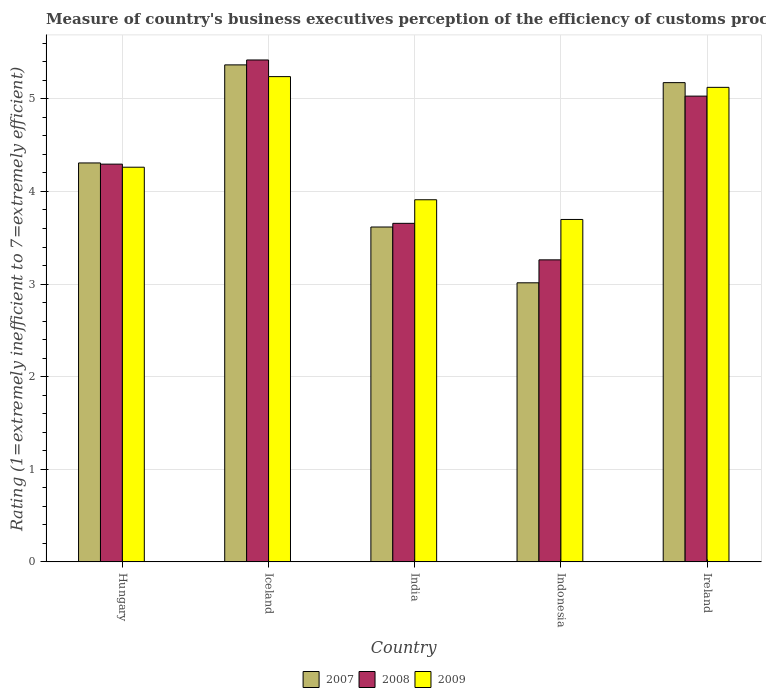How many different coloured bars are there?
Give a very brief answer. 3. How many bars are there on the 3rd tick from the right?
Give a very brief answer. 3. What is the label of the 5th group of bars from the left?
Your answer should be very brief. Ireland. What is the rating of the efficiency of customs procedure in 2008 in India?
Your answer should be compact. 3.66. Across all countries, what is the maximum rating of the efficiency of customs procedure in 2009?
Provide a short and direct response. 5.24. Across all countries, what is the minimum rating of the efficiency of customs procedure in 2008?
Your answer should be very brief. 3.26. In which country was the rating of the efficiency of customs procedure in 2009 minimum?
Make the answer very short. Indonesia. What is the total rating of the efficiency of customs procedure in 2008 in the graph?
Keep it short and to the point. 21.66. What is the difference between the rating of the efficiency of customs procedure in 2008 in Iceland and that in Ireland?
Provide a succinct answer. 0.39. What is the difference between the rating of the efficiency of customs procedure in 2007 in India and the rating of the efficiency of customs procedure in 2008 in Indonesia?
Your answer should be compact. 0.35. What is the average rating of the efficiency of customs procedure in 2007 per country?
Ensure brevity in your answer.  4.3. What is the difference between the rating of the efficiency of customs procedure of/in 2009 and rating of the efficiency of customs procedure of/in 2008 in Iceland?
Your answer should be very brief. -0.18. What is the ratio of the rating of the efficiency of customs procedure in 2007 in Hungary to that in Iceland?
Provide a succinct answer. 0.8. Is the rating of the efficiency of customs procedure in 2007 in Hungary less than that in India?
Make the answer very short. No. What is the difference between the highest and the second highest rating of the efficiency of customs procedure in 2009?
Make the answer very short. 0.86. What is the difference between the highest and the lowest rating of the efficiency of customs procedure in 2007?
Ensure brevity in your answer.  2.35. What does the 3rd bar from the right in Iceland represents?
Your answer should be very brief. 2007. Are all the bars in the graph horizontal?
Offer a very short reply. No. What is the difference between two consecutive major ticks on the Y-axis?
Provide a succinct answer. 1. Does the graph contain grids?
Your answer should be compact. Yes. Where does the legend appear in the graph?
Your answer should be very brief. Bottom center. What is the title of the graph?
Keep it short and to the point. Measure of country's business executives perception of the efficiency of customs procedures. Does "1978" appear as one of the legend labels in the graph?
Ensure brevity in your answer.  No. What is the label or title of the Y-axis?
Your response must be concise. Rating (1=extremely inefficient to 7=extremely efficient). What is the Rating (1=extremely inefficient to 7=extremely efficient) of 2007 in Hungary?
Make the answer very short. 4.31. What is the Rating (1=extremely inefficient to 7=extremely efficient) of 2008 in Hungary?
Provide a short and direct response. 4.29. What is the Rating (1=extremely inefficient to 7=extremely efficient) in 2009 in Hungary?
Offer a terse response. 4.26. What is the Rating (1=extremely inefficient to 7=extremely efficient) in 2007 in Iceland?
Give a very brief answer. 5.37. What is the Rating (1=extremely inefficient to 7=extremely efficient) in 2008 in Iceland?
Provide a succinct answer. 5.42. What is the Rating (1=extremely inefficient to 7=extremely efficient) in 2009 in Iceland?
Your response must be concise. 5.24. What is the Rating (1=extremely inefficient to 7=extremely efficient) in 2007 in India?
Ensure brevity in your answer.  3.62. What is the Rating (1=extremely inefficient to 7=extremely efficient) of 2008 in India?
Your answer should be very brief. 3.66. What is the Rating (1=extremely inefficient to 7=extremely efficient) in 2009 in India?
Keep it short and to the point. 3.91. What is the Rating (1=extremely inefficient to 7=extremely efficient) in 2007 in Indonesia?
Keep it short and to the point. 3.01. What is the Rating (1=extremely inefficient to 7=extremely efficient) in 2008 in Indonesia?
Your answer should be very brief. 3.26. What is the Rating (1=extremely inefficient to 7=extremely efficient) in 2009 in Indonesia?
Your answer should be compact. 3.7. What is the Rating (1=extremely inefficient to 7=extremely efficient) of 2007 in Ireland?
Offer a terse response. 5.17. What is the Rating (1=extremely inefficient to 7=extremely efficient) in 2008 in Ireland?
Provide a succinct answer. 5.03. What is the Rating (1=extremely inefficient to 7=extremely efficient) in 2009 in Ireland?
Keep it short and to the point. 5.12. Across all countries, what is the maximum Rating (1=extremely inefficient to 7=extremely efficient) in 2007?
Offer a terse response. 5.37. Across all countries, what is the maximum Rating (1=extremely inefficient to 7=extremely efficient) of 2008?
Make the answer very short. 5.42. Across all countries, what is the maximum Rating (1=extremely inefficient to 7=extremely efficient) of 2009?
Give a very brief answer. 5.24. Across all countries, what is the minimum Rating (1=extremely inefficient to 7=extremely efficient) of 2007?
Offer a terse response. 3.01. Across all countries, what is the minimum Rating (1=extremely inefficient to 7=extremely efficient) of 2008?
Ensure brevity in your answer.  3.26. Across all countries, what is the minimum Rating (1=extremely inefficient to 7=extremely efficient) in 2009?
Provide a short and direct response. 3.7. What is the total Rating (1=extremely inefficient to 7=extremely efficient) of 2007 in the graph?
Your answer should be very brief. 21.48. What is the total Rating (1=extremely inefficient to 7=extremely efficient) in 2008 in the graph?
Make the answer very short. 21.66. What is the total Rating (1=extremely inefficient to 7=extremely efficient) of 2009 in the graph?
Your response must be concise. 22.23. What is the difference between the Rating (1=extremely inefficient to 7=extremely efficient) of 2007 in Hungary and that in Iceland?
Your answer should be very brief. -1.06. What is the difference between the Rating (1=extremely inefficient to 7=extremely efficient) in 2008 in Hungary and that in Iceland?
Your answer should be compact. -1.12. What is the difference between the Rating (1=extremely inefficient to 7=extremely efficient) of 2009 in Hungary and that in Iceland?
Provide a succinct answer. -0.98. What is the difference between the Rating (1=extremely inefficient to 7=extremely efficient) of 2007 in Hungary and that in India?
Offer a terse response. 0.69. What is the difference between the Rating (1=extremely inefficient to 7=extremely efficient) in 2008 in Hungary and that in India?
Provide a short and direct response. 0.64. What is the difference between the Rating (1=extremely inefficient to 7=extremely efficient) in 2009 in Hungary and that in India?
Offer a very short reply. 0.35. What is the difference between the Rating (1=extremely inefficient to 7=extremely efficient) of 2007 in Hungary and that in Indonesia?
Provide a short and direct response. 1.29. What is the difference between the Rating (1=extremely inefficient to 7=extremely efficient) of 2008 in Hungary and that in Indonesia?
Your answer should be very brief. 1.03. What is the difference between the Rating (1=extremely inefficient to 7=extremely efficient) of 2009 in Hungary and that in Indonesia?
Keep it short and to the point. 0.56. What is the difference between the Rating (1=extremely inefficient to 7=extremely efficient) of 2007 in Hungary and that in Ireland?
Offer a terse response. -0.87. What is the difference between the Rating (1=extremely inefficient to 7=extremely efficient) in 2008 in Hungary and that in Ireland?
Your answer should be very brief. -0.73. What is the difference between the Rating (1=extremely inefficient to 7=extremely efficient) of 2009 in Hungary and that in Ireland?
Make the answer very short. -0.86. What is the difference between the Rating (1=extremely inefficient to 7=extremely efficient) of 2007 in Iceland and that in India?
Provide a succinct answer. 1.75. What is the difference between the Rating (1=extremely inefficient to 7=extremely efficient) of 2008 in Iceland and that in India?
Your response must be concise. 1.76. What is the difference between the Rating (1=extremely inefficient to 7=extremely efficient) in 2009 in Iceland and that in India?
Give a very brief answer. 1.33. What is the difference between the Rating (1=extremely inefficient to 7=extremely efficient) in 2007 in Iceland and that in Indonesia?
Ensure brevity in your answer.  2.35. What is the difference between the Rating (1=extremely inefficient to 7=extremely efficient) in 2008 in Iceland and that in Indonesia?
Make the answer very short. 2.16. What is the difference between the Rating (1=extremely inefficient to 7=extremely efficient) in 2009 in Iceland and that in Indonesia?
Your answer should be compact. 1.54. What is the difference between the Rating (1=extremely inefficient to 7=extremely efficient) of 2007 in Iceland and that in Ireland?
Keep it short and to the point. 0.19. What is the difference between the Rating (1=extremely inefficient to 7=extremely efficient) of 2008 in Iceland and that in Ireland?
Offer a terse response. 0.39. What is the difference between the Rating (1=extremely inefficient to 7=extremely efficient) of 2009 in Iceland and that in Ireland?
Offer a terse response. 0.12. What is the difference between the Rating (1=extremely inefficient to 7=extremely efficient) of 2007 in India and that in Indonesia?
Give a very brief answer. 0.6. What is the difference between the Rating (1=extremely inefficient to 7=extremely efficient) of 2008 in India and that in Indonesia?
Your answer should be compact. 0.39. What is the difference between the Rating (1=extremely inefficient to 7=extremely efficient) of 2009 in India and that in Indonesia?
Your answer should be very brief. 0.21. What is the difference between the Rating (1=extremely inefficient to 7=extremely efficient) of 2007 in India and that in Ireland?
Provide a succinct answer. -1.56. What is the difference between the Rating (1=extremely inefficient to 7=extremely efficient) in 2008 in India and that in Ireland?
Your answer should be compact. -1.37. What is the difference between the Rating (1=extremely inefficient to 7=extremely efficient) in 2009 in India and that in Ireland?
Your response must be concise. -1.21. What is the difference between the Rating (1=extremely inefficient to 7=extremely efficient) in 2007 in Indonesia and that in Ireland?
Provide a short and direct response. -2.16. What is the difference between the Rating (1=extremely inefficient to 7=extremely efficient) in 2008 in Indonesia and that in Ireland?
Provide a short and direct response. -1.77. What is the difference between the Rating (1=extremely inefficient to 7=extremely efficient) of 2009 in Indonesia and that in Ireland?
Your answer should be compact. -1.43. What is the difference between the Rating (1=extremely inefficient to 7=extremely efficient) of 2007 in Hungary and the Rating (1=extremely inefficient to 7=extremely efficient) of 2008 in Iceland?
Your answer should be very brief. -1.11. What is the difference between the Rating (1=extremely inefficient to 7=extremely efficient) of 2007 in Hungary and the Rating (1=extremely inefficient to 7=extremely efficient) of 2009 in Iceland?
Give a very brief answer. -0.93. What is the difference between the Rating (1=extremely inefficient to 7=extremely efficient) of 2008 in Hungary and the Rating (1=extremely inefficient to 7=extremely efficient) of 2009 in Iceland?
Ensure brevity in your answer.  -0.94. What is the difference between the Rating (1=extremely inefficient to 7=extremely efficient) of 2007 in Hungary and the Rating (1=extremely inefficient to 7=extremely efficient) of 2008 in India?
Make the answer very short. 0.65. What is the difference between the Rating (1=extremely inefficient to 7=extremely efficient) of 2007 in Hungary and the Rating (1=extremely inefficient to 7=extremely efficient) of 2009 in India?
Offer a very short reply. 0.4. What is the difference between the Rating (1=extremely inefficient to 7=extremely efficient) in 2008 in Hungary and the Rating (1=extremely inefficient to 7=extremely efficient) in 2009 in India?
Offer a terse response. 0.38. What is the difference between the Rating (1=extremely inefficient to 7=extremely efficient) of 2007 in Hungary and the Rating (1=extremely inefficient to 7=extremely efficient) of 2008 in Indonesia?
Keep it short and to the point. 1.05. What is the difference between the Rating (1=extremely inefficient to 7=extremely efficient) in 2007 in Hungary and the Rating (1=extremely inefficient to 7=extremely efficient) in 2009 in Indonesia?
Your response must be concise. 0.61. What is the difference between the Rating (1=extremely inefficient to 7=extremely efficient) of 2008 in Hungary and the Rating (1=extremely inefficient to 7=extremely efficient) of 2009 in Indonesia?
Provide a short and direct response. 0.6. What is the difference between the Rating (1=extremely inefficient to 7=extremely efficient) of 2007 in Hungary and the Rating (1=extremely inefficient to 7=extremely efficient) of 2008 in Ireland?
Give a very brief answer. -0.72. What is the difference between the Rating (1=extremely inefficient to 7=extremely efficient) in 2007 in Hungary and the Rating (1=extremely inefficient to 7=extremely efficient) in 2009 in Ireland?
Your answer should be compact. -0.82. What is the difference between the Rating (1=extremely inefficient to 7=extremely efficient) in 2008 in Hungary and the Rating (1=extremely inefficient to 7=extremely efficient) in 2009 in Ireland?
Offer a very short reply. -0.83. What is the difference between the Rating (1=extremely inefficient to 7=extremely efficient) of 2007 in Iceland and the Rating (1=extremely inefficient to 7=extremely efficient) of 2008 in India?
Make the answer very short. 1.71. What is the difference between the Rating (1=extremely inefficient to 7=extremely efficient) in 2007 in Iceland and the Rating (1=extremely inefficient to 7=extremely efficient) in 2009 in India?
Offer a very short reply. 1.46. What is the difference between the Rating (1=extremely inefficient to 7=extremely efficient) of 2008 in Iceland and the Rating (1=extremely inefficient to 7=extremely efficient) of 2009 in India?
Your answer should be very brief. 1.51. What is the difference between the Rating (1=extremely inefficient to 7=extremely efficient) of 2007 in Iceland and the Rating (1=extremely inefficient to 7=extremely efficient) of 2008 in Indonesia?
Provide a succinct answer. 2.11. What is the difference between the Rating (1=extremely inefficient to 7=extremely efficient) of 2007 in Iceland and the Rating (1=extremely inefficient to 7=extremely efficient) of 2009 in Indonesia?
Provide a succinct answer. 1.67. What is the difference between the Rating (1=extremely inefficient to 7=extremely efficient) of 2008 in Iceland and the Rating (1=extremely inefficient to 7=extremely efficient) of 2009 in Indonesia?
Keep it short and to the point. 1.72. What is the difference between the Rating (1=extremely inefficient to 7=extremely efficient) of 2007 in Iceland and the Rating (1=extremely inefficient to 7=extremely efficient) of 2008 in Ireland?
Make the answer very short. 0.34. What is the difference between the Rating (1=extremely inefficient to 7=extremely efficient) in 2007 in Iceland and the Rating (1=extremely inefficient to 7=extremely efficient) in 2009 in Ireland?
Give a very brief answer. 0.24. What is the difference between the Rating (1=extremely inefficient to 7=extremely efficient) in 2008 in Iceland and the Rating (1=extremely inefficient to 7=extremely efficient) in 2009 in Ireland?
Give a very brief answer. 0.3. What is the difference between the Rating (1=extremely inefficient to 7=extremely efficient) of 2007 in India and the Rating (1=extremely inefficient to 7=extremely efficient) of 2008 in Indonesia?
Your answer should be very brief. 0.35. What is the difference between the Rating (1=extremely inefficient to 7=extremely efficient) of 2007 in India and the Rating (1=extremely inefficient to 7=extremely efficient) of 2009 in Indonesia?
Offer a very short reply. -0.08. What is the difference between the Rating (1=extremely inefficient to 7=extremely efficient) of 2008 in India and the Rating (1=extremely inefficient to 7=extremely efficient) of 2009 in Indonesia?
Offer a very short reply. -0.04. What is the difference between the Rating (1=extremely inefficient to 7=extremely efficient) of 2007 in India and the Rating (1=extremely inefficient to 7=extremely efficient) of 2008 in Ireland?
Your answer should be compact. -1.41. What is the difference between the Rating (1=extremely inefficient to 7=extremely efficient) of 2007 in India and the Rating (1=extremely inefficient to 7=extremely efficient) of 2009 in Ireland?
Ensure brevity in your answer.  -1.51. What is the difference between the Rating (1=extremely inefficient to 7=extremely efficient) in 2008 in India and the Rating (1=extremely inefficient to 7=extremely efficient) in 2009 in Ireland?
Make the answer very short. -1.47. What is the difference between the Rating (1=extremely inefficient to 7=extremely efficient) in 2007 in Indonesia and the Rating (1=extremely inefficient to 7=extremely efficient) in 2008 in Ireland?
Your answer should be very brief. -2.02. What is the difference between the Rating (1=extremely inefficient to 7=extremely efficient) in 2007 in Indonesia and the Rating (1=extremely inefficient to 7=extremely efficient) in 2009 in Ireland?
Your answer should be very brief. -2.11. What is the difference between the Rating (1=extremely inefficient to 7=extremely efficient) of 2008 in Indonesia and the Rating (1=extremely inefficient to 7=extremely efficient) of 2009 in Ireland?
Your response must be concise. -1.86. What is the average Rating (1=extremely inefficient to 7=extremely efficient) of 2007 per country?
Keep it short and to the point. 4.3. What is the average Rating (1=extremely inefficient to 7=extremely efficient) of 2008 per country?
Ensure brevity in your answer.  4.33. What is the average Rating (1=extremely inefficient to 7=extremely efficient) in 2009 per country?
Ensure brevity in your answer.  4.45. What is the difference between the Rating (1=extremely inefficient to 7=extremely efficient) of 2007 and Rating (1=extremely inefficient to 7=extremely efficient) of 2008 in Hungary?
Provide a succinct answer. 0.01. What is the difference between the Rating (1=extremely inefficient to 7=extremely efficient) of 2007 and Rating (1=extremely inefficient to 7=extremely efficient) of 2009 in Hungary?
Your response must be concise. 0.05. What is the difference between the Rating (1=extremely inefficient to 7=extremely efficient) in 2008 and Rating (1=extremely inefficient to 7=extremely efficient) in 2009 in Hungary?
Offer a very short reply. 0.03. What is the difference between the Rating (1=extremely inefficient to 7=extremely efficient) in 2007 and Rating (1=extremely inefficient to 7=extremely efficient) in 2008 in Iceland?
Provide a succinct answer. -0.05. What is the difference between the Rating (1=extremely inefficient to 7=extremely efficient) of 2007 and Rating (1=extremely inefficient to 7=extremely efficient) of 2009 in Iceland?
Your answer should be compact. 0.13. What is the difference between the Rating (1=extremely inefficient to 7=extremely efficient) of 2008 and Rating (1=extremely inefficient to 7=extremely efficient) of 2009 in Iceland?
Ensure brevity in your answer.  0.18. What is the difference between the Rating (1=extremely inefficient to 7=extremely efficient) in 2007 and Rating (1=extremely inefficient to 7=extremely efficient) in 2008 in India?
Ensure brevity in your answer.  -0.04. What is the difference between the Rating (1=extremely inefficient to 7=extremely efficient) of 2007 and Rating (1=extremely inefficient to 7=extremely efficient) of 2009 in India?
Provide a succinct answer. -0.29. What is the difference between the Rating (1=extremely inefficient to 7=extremely efficient) in 2008 and Rating (1=extremely inefficient to 7=extremely efficient) in 2009 in India?
Your answer should be very brief. -0.25. What is the difference between the Rating (1=extremely inefficient to 7=extremely efficient) of 2007 and Rating (1=extremely inefficient to 7=extremely efficient) of 2008 in Indonesia?
Make the answer very short. -0.25. What is the difference between the Rating (1=extremely inefficient to 7=extremely efficient) of 2007 and Rating (1=extremely inefficient to 7=extremely efficient) of 2009 in Indonesia?
Provide a succinct answer. -0.68. What is the difference between the Rating (1=extremely inefficient to 7=extremely efficient) in 2008 and Rating (1=extremely inefficient to 7=extremely efficient) in 2009 in Indonesia?
Your answer should be compact. -0.44. What is the difference between the Rating (1=extremely inefficient to 7=extremely efficient) of 2007 and Rating (1=extremely inefficient to 7=extremely efficient) of 2008 in Ireland?
Give a very brief answer. 0.15. What is the difference between the Rating (1=extremely inefficient to 7=extremely efficient) of 2007 and Rating (1=extremely inefficient to 7=extremely efficient) of 2009 in Ireland?
Your answer should be very brief. 0.05. What is the difference between the Rating (1=extremely inefficient to 7=extremely efficient) of 2008 and Rating (1=extremely inefficient to 7=extremely efficient) of 2009 in Ireland?
Make the answer very short. -0.09. What is the ratio of the Rating (1=extremely inefficient to 7=extremely efficient) of 2007 in Hungary to that in Iceland?
Provide a short and direct response. 0.8. What is the ratio of the Rating (1=extremely inefficient to 7=extremely efficient) in 2008 in Hungary to that in Iceland?
Your response must be concise. 0.79. What is the ratio of the Rating (1=extremely inefficient to 7=extremely efficient) of 2009 in Hungary to that in Iceland?
Offer a very short reply. 0.81. What is the ratio of the Rating (1=extremely inefficient to 7=extremely efficient) of 2007 in Hungary to that in India?
Keep it short and to the point. 1.19. What is the ratio of the Rating (1=extremely inefficient to 7=extremely efficient) in 2008 in Hungary to that in India?
Your response must be concise. 1.17. What is the ratio of the Rating (1=extremely inefficient to 7=extremely efficient) in 2009 in Hungary to that in India?
Offer a very short reply. 1.09. What is the ratio of the Rating (1=extremely inefficient to 7=extremely efficient) of 2007 in Hungary to that in Indonesia?
Make the answer very short. 1.43. What is the ratio of the Rating (1=extremely inefficient to 7=extremely efficient) in 2008 in Hungary to that in Indonesia?
Offer a terse response. 1.32. What is the ratio of the Rating (1=extremely inefficient to 7=extremely efficient) in 2009 in Hungary to that in Indonesia?
Make the answer very short. 1.15. What is the ratio of the Rating (1=extremely inefficient to 7=extremely efficient) in 2007 in Hungary to that in Ireland?
Provide a short and direct response. 0.83. What is the ratio of the Rating (1=extremely inefficient to 7=extremely efficient) in 2008 in Hungary to that in Ireland?
Ensure brevity in your answer.  0.85. What is the ratio of the Rating (1=extremely inefficient to 7=extremely efficient) in 2009 in Hungary to that in Ireland?
Provide a succinct answer. 0.83. What is the ratio of the Rating (1=extremely inefficient to 7=extremely efficient) in 2007 in Iceland to that in India?
Make the answer very short. 1.48. What is the ratio of the Rating (1=extremely inefficient to 7=extremely efficient) of 2008 in Iceland to that in India?
Provide a short and direct response. 1.48. What is the ratio of the Rating (1=extremely inefficient to 7=extremely efficient) in 2009 in Iceland to that in India?
Your answer should be very brief. 1.34. What is the ratio of the Rating (1=extremely inefficient to 7=extremely efficient) in 2007 in Iceland to that in Indonesia?
Offer a very short reply. 1.78. What is the ratio of the Rating (1=extremely inefficient to 7=extremely efficient) in 2008 in Iceland to that in Indonesia?
Your response must be concise. 1.66. What is the ratio of the Rating (1=extremely inefficient to 7=extremely efficient) of 2009 in Iceland to that in Indonesia?
Provide a short and direct response. 1.42. What is the ratio of the Rating (1=extremely inefficient to 7=extremely efficient) of 2007 in Iceland to that in Ireland?
Offer a very short reply. 1.04. What is the ratio of the Rating (1=extremely inefficient to 7=extremely efficient) of 2008 in Iceland to that in Ireland?
Your answer should be compact. 1.08. What is the ratio of the Rating (1=extremely inefficient to 7=extremely efficient) of 2009 in Iceland to that in Ireland?
Offer a terse response. 1.02. What is the ratio of the Rating (1=extremely inefficient to 7=extremely efficient) in 2007 in India to that in Indonesia?
Your answer should be very brief. 1.2. What is the ratio of the Rating (1=extremely inefficient to 7=extremely efficient) of 2008 in India to that in Indonesia?
Provide a succinct answer. 1.12. What is the ratio of the Rating (1=extremely inefficient to 7=extremely efficient) of 2009 in India to that in Indonesia?
Provide a short and direct response. 1.06. What is the ratio of the Rating (1=extremely inefficient to 7=extremely efficient) in 2007 in India to that in Ireland?
Offer a terse response. 0.7. What is the ratio of the Rating (1=extremely inefficient to 7=extremely efficient) of 2008 in India to that in Ireland?
Provide a short and direct response. 0.73. What is the ratio of the Rating (1=extremely inefficient to 7=extremely efficient) of 2009 in India to that in Ireland?
Provide a short and direct response. 0.76. What is the ratio of the Rating (1=extremely inefficient to 7=extremely efficient) of 2007 in Indonesia to that in Ireland?
Your response must be concise. 0.58. What is the ratio of the Rating (1=extremely inefficient to 7=extremely efficient) in 2008 in Indonesia to that in Ireland?
Keep it short and to the point. 0.65. What is the ratio of the Rating (1=extremely inefficient to 7=extremely efficient) of 2009 in Indonesia to that in Ireland?
Ensure brevity in your answer.  0.72. What is the difference between the highest and the second highest Rating (1=extremely inefficient to 7=extremely efficient) of 2007?
Ensure brevity in your answer.  0.19. What is the difference between the highest and the second highest Rating (1=extremely inefficient to 7=extremely efficient) in 2008?
Ensure brevity in your answer.  0.39. What is the difference between the highest and the second highest Rating (1=extremely inefficient to 7=extremely efficient) of 2009?
Give a very brief answer. 0.12. What is the difference between the highest and the lowest Rating (1=extremely inefficient to 7=extremely efficient) in 2007?
Provide a succinct answer. 2.35. What is the difference between the highest and the lowest Rating (1=extremely inefficient to 7=extremely efficient) of 2008?
Your answer should be very brief. 2.16. What is the difference between the highest and the lowest Rating (1=extremely inefficient to 7=extremely efficient) in 2009?
Give a very brief answer. 1.54. 